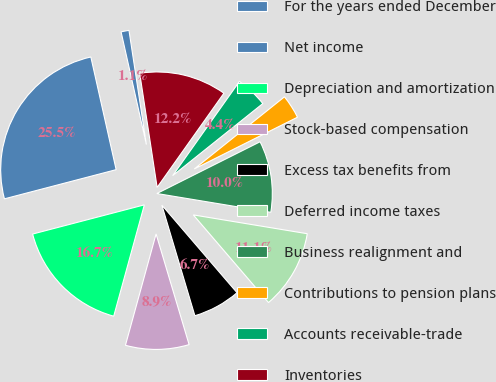<chart> <loc_0><loc_0><loc_500><loc_500><pie_chart><fcel>For the years ended December<fcel>Net income<fcel>Depreciation and amortization<fcel>Stock-based compensation<fcel>Excess tax benefits from<fcel>Deferred income taxes<fcel>Business realignment and<fcel>Contributions to pension plans<fcel>Accounts receivable-trade<fcel>Inventories<nl><fcel>1.11%<fcel>25.55%<fcel>16.66%<fcel>8.89%<fcel>6.67%<fcel>11.11%<fcel>10.0%<fcel>3.34%<fcel>4.45%<fcel>12.22%<nl></chart> 